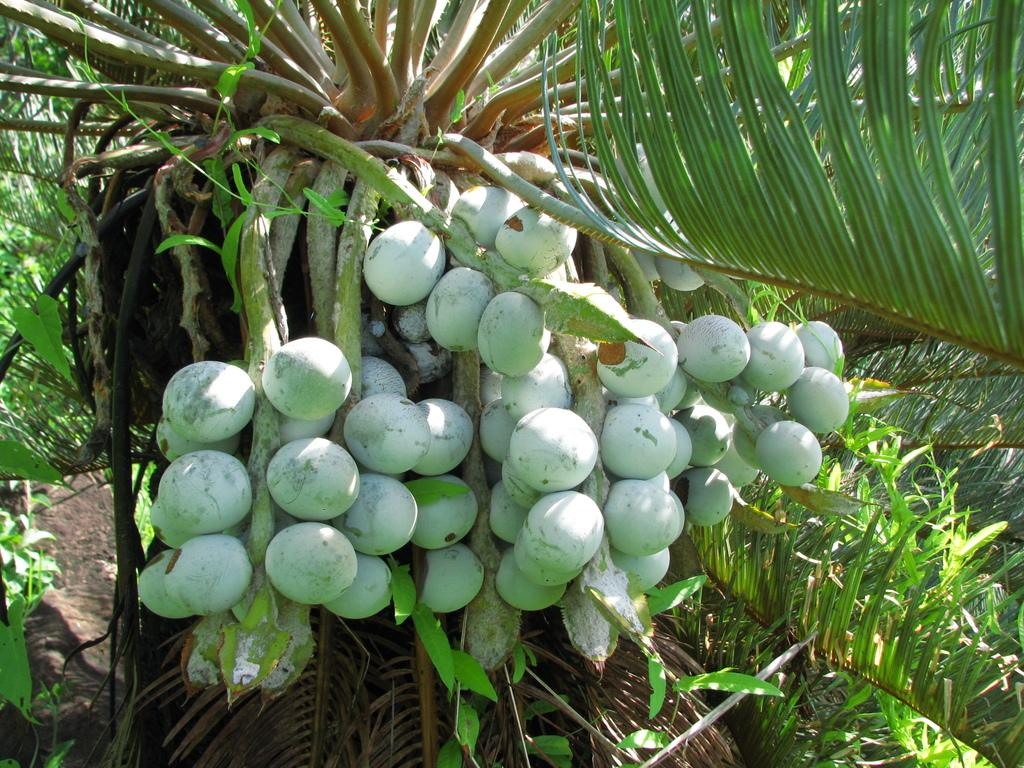What type of vegetation can be seen in the image? There are trees in the image. Are there any fruits visible on the trees in the image? Yes, there are fruits on a tree in the image. How many beds can be seen in the image? There are no beds present in the image. What type of comparison can be made between the fruits and wax in the image? There is no reference to wax in the image, so it is not possible to make any comparison between the fruits and wax. 